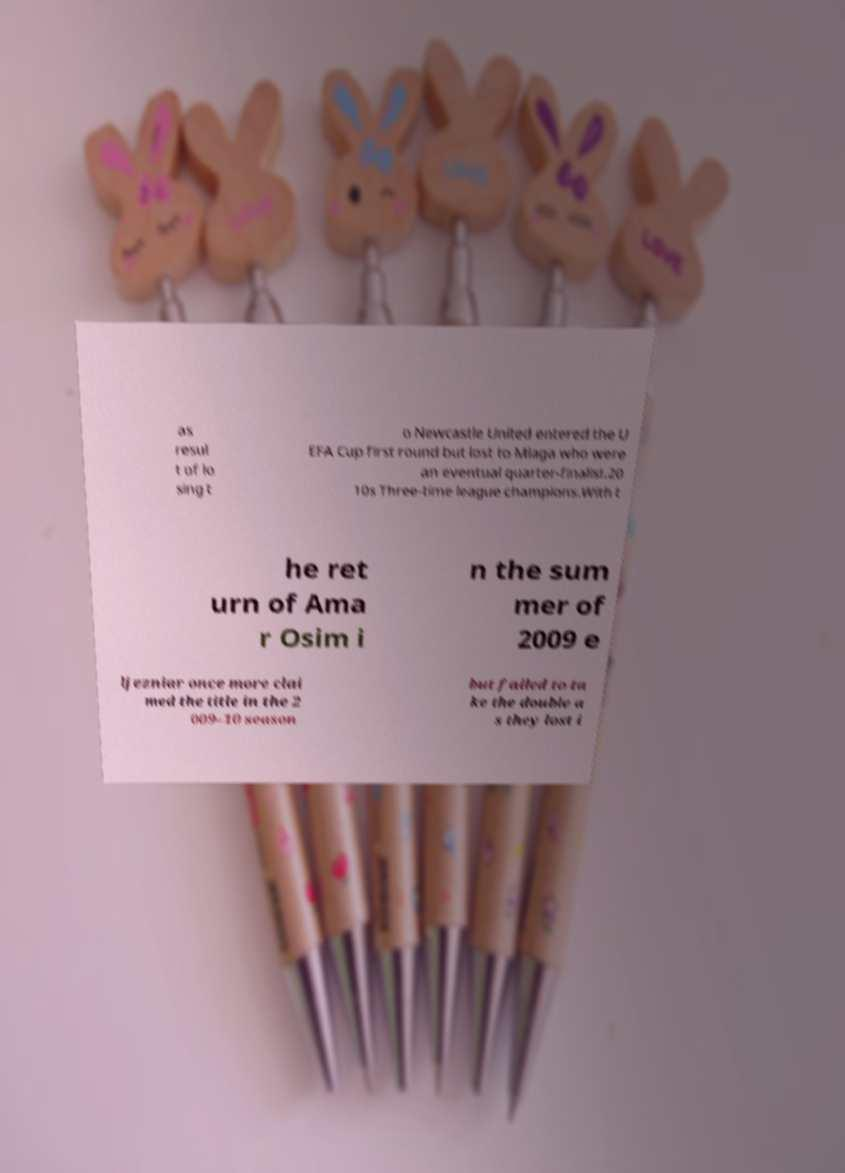For documentation purposes, I need the text within this image transcribed. Could you provide that? as resul t of lo sing t o Newcastle United entered the U EFA Cup first round but lost to Mlaga who were an eventual quarter-finalist.20 10s Three-time league champions.With t he ret urn of Ama r Osim i n the sum mer of 2009 e ljezniar once more clai med the title in the 2 009–10 season but failed to ta ke the double a s they lost i 